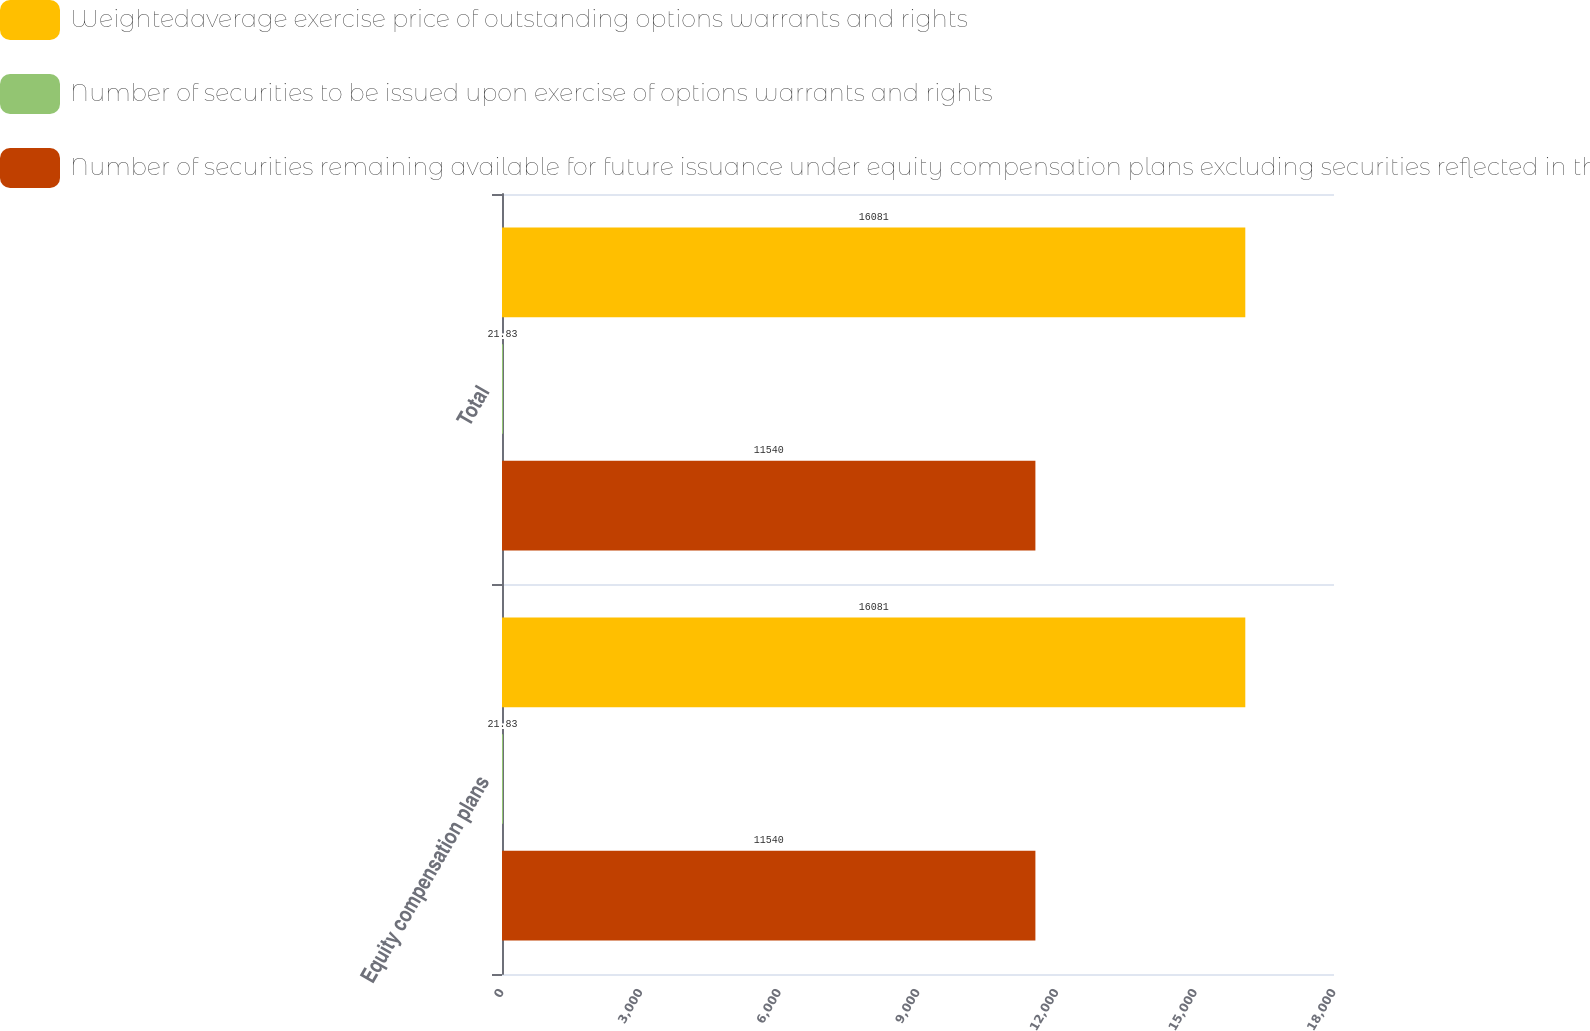Convert chart. <chart><loc_0><loc_0><loc_500><loc_500><stacked_bar_chart><ecel><fcel>Equity compensation plans<fcel>Total<nl><fcel>Weightedaverage exercise price of outstanding options warrants and rights<fcel>16081<fcel>16081<nl><fcel>Number of securities to be issued upon exercise of options warrants and rights<fcel>21.83<fcel>21.83<nl><fcel>Number of securities remaining available for future issuance under equity compensation plans excluding securities reflected in the first column in 000s except per share amounts<fcel>11540<fcel>11540<nl></chart> 